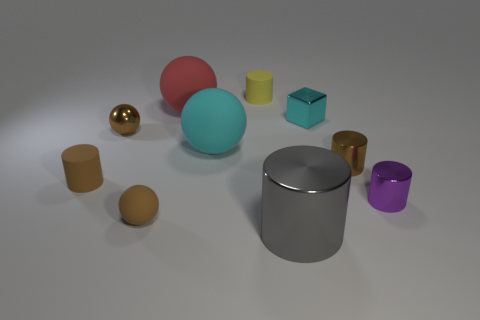Subtract 2 cylinders. How many cylinders are left? 3 Subtract all large cylinders. How many cylinders are left? 4 Subtract all yellow cylinders. How many cylinders are left? 4 Subtract all red cylinders. Subtract all purple cubes. How many cylinders are left? 5 Subtract all cubes. How many objects are left? 9 Subtract all tiny brown cylinders. Subtract all yellow rubber cylinders. How many objects are left? 7 Add 1 small matte spheres. How many small matte spheres are left? 2 Add 7 gray metallic cylinders. How many gray metallic cylinders exist? 8 Subtract 0 blue cubes. How many objects are left? 10 